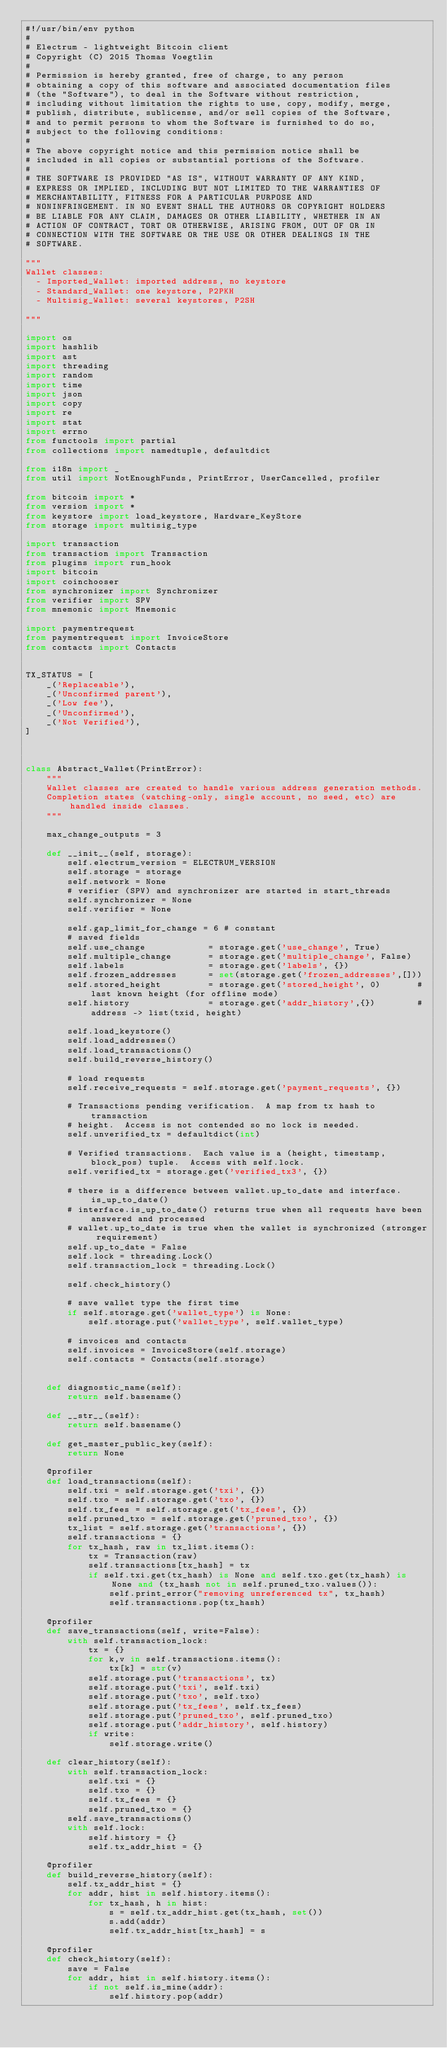Convert code to text. <code><loc_0><loc_0><loc_500><loc_500><_Python_>#!/usr/bin/env python
#
# Electrum - lightweight Bitcoin client
# Copyright (C) 2015 Thomas Voegtlin
#
# Permission is hereby granted, free of charge, to any person
# obtaining a copy of this software and associated documentation files
# (the "Software"), to deal in the Software without restriction,
# including without limitation the rights to use, copy, modify, merge,
# publish, distribute, sublicense, and/or sell copies of the Software,
# and to permit persons to whom the Software is furnished to do so,
# subject to the following conditions:
#
# The above copyright notice and this permission notice shall be
# included in all copies or substantial portions of the Software.
#
# THE SOFTWARE IS PROVIDED "AS IS", WITHOUT WARRANTY OF ANY KIND,
# EXPRESS OR IMPLIED, INCLUDING BUT NOT LIMITED TO THE WARRANTIES OF
# MERCHANTABILITY, FITNESS FOR A PARTICULAR PURPOSE AND
# NONINFRINGEMENT. IN NO EVENT SHALL THE AUTHORS OR COPYRIGHT HOLDERS
# BE LIABLE FOR ANY CLAIM, DAMAGES OR OTHER LIABILITY, WHETHER IN AN
# ACTION OF CONTRACT, TORT OR OTHERWISE, ARISING FROM, OUT OF OR IN
# CONNECTION WITH THE SOFTWARE OR THE USE OR OTHER DEALINGS IN THE
# SOFTWARE.

"""
Wallet classes:
  - Imported_Wallet: imported address, no keystore
  - Standard_Wallet: one keystore, P2PKH
  - Multisig_Wallet: several keystores, P2SH

"""

import os
import hashlib
import ast
import threading
import random
import time
import json
import copy
import re
import stat
import errno
from functools import partial
from collections import namedtuple, defaultdict

from i18n import _
from util import NotEnoughFunds, PrintError, UserCancelled, profiler

from bitcoin import *
from version import *
from keystore import load_keystore, Hardware_KeyStore
from storage import multisig_type

import transaction
from transaction import Transaction
from plugins import run_hook
import bitcoin
import coinchooser
from synchronizer import Synchronizer
from verifier import SPV
from mnemonic import Mnemonic

import paymentrequest
from paymentrequest import InvoiceStore
from contacts import Contacts


TX_STATUS = [
    _('Replaceable'),
    _('Unconfirmed parent'),
    _('Low fee'),
    _('Unconfirmed'),
    _('Not Verified'),
]



class Abstract_Wallet(PrintError):
    """
    Wallet classes are created to handle various address generation methods.
    Completion states (watching-only, single account, no seed, etc) are handled inside classes.
    """

    max_change_outputs = 3

    def __init__(self, storage):
        self.electrum_version = ELECTRUM_VERSION
        self.storage = storage
        self.network = None
        # verifier (SPV) and synchronizer are started in start_threads
        self.synchronizer = None
        self.verifier = None

        self.gap_limit_for_change = 6 # constant
        # saved fields
        self.use_change            = storage.get('use_change', True)
        self.multiple_change       = storage.get('multiple_change', False)
        self.labels                = storage.get('labels', {})
        self.frozen_addresses      = set(storage.get('frozen_addresses',[]))
        self.stored_height         = storage.get('stored_height', 0)       # last known height (for offline mode)
        self.history               = storage.get('addr_history',{})        # address -> list(txid, height)

        self.load_keystore()
        self.load_addresses()
        self.load_transactions()
        self.build_reverse_history()

        # load requests
        self.receive_requests = self.storage.get('payment_requests', {})

        # Transactions pending verification.  A map from tx hash to transaction
        # height.  Access is not contended so no lock is needed.
        self.unverified_tx = defaultdict(int)

        # Verified transactions.  Each value is a (height, timestamp, block_pos) tuple.  Access with self.lock.
        self.verified_tx = storage.get('verified_tx3', {})

        # there is a difference between wallet.up_to_date and interface.is_up_to_date()
        # interface.is_up_to_date() returns true when all requests have been answered and processed
        # wallet.up_to_date is true when the wallet is synchronized (stronger requirement)
        self.up_to_date = False
        self.lock = threading.Lock()
        self.transaction_lock = threading.Lock()

        self.check_history()

        # save wallet type the first time
        if self.storage.get('wallet_type') is None:
            self.storage.put('wallet_type', self.wallet_type)

        # invoices and contacts
        self.invoices = InvoiceStore(self.storage)
        self.contacts = Contacts(self.storage)


    def diagnostic_name(self):
        return self.basename()

    def __str__(self):
        return self.basename()

    def get_master_public_key(self):
        return None

    @profiler
    def load_transactions(self):
        self.txi = self.storage.get('txi', {})
        self.txo = self.storage.get('txo', {})
        self.tx_fees = self.storage.get('tx_fees', {})
        self.pruned_txo = self.storage.get('pruned_txo', {})
        tx_list = self.storage.get('transactions', {})
        self.transactions = {}
        for tx_hash, raw in tx_list.items():
            tx = Transaction(raw)
            self.transactions[tx_hash] = tx
            if self.txi.get(tx_hash) is None and self.txo.get(tx_hash) is None and (tx_hash not in self.pruned_txo.values()):
                self.print_error("removing unreferenced tx", tx_hash)
                self.transactions.pop(tx_hash)

    @profiler
    def save_transactions(self, write=False):
        with self.transaction_lock:
            tx = {}
            for k,v in self.transactions.items():
                tx[k] = str(v)
            self.storage.put('transactions', tx)
            self.storage.put('txi', self.txi)
            self.storage.put('txo', self.txo)
            self.storage.put('tx_fees', self.tx_fees)
            self.storage.put('pruned_txo', self.pruned_txo)
            self.storage.put('addr_history', self.history)
            if write:
                self.storage.write()

    def clear_history(self):
        with self.transaction_lock:
            self.txi = {}
            self.txo = {}
            self.tx_fees = {}
            self.pruned_txo = {}
        self.save_transactions()
        with self.lock:
            self.history = {}
            self.tx_addr_hist = {}

    @profiler
    def build_reverse_history(self):
        self.tx_addr_hist = {}
        for addr, hist in self.history.items():
            for tx_hash, h in hist:
                s = self.tx_addr_hist.get(tx_hash, set())
                s.add(addr)
                self.tx_addr_hist[tx_hash] = s

    @profiler
    def check_history(self):
        save = False
        for addr, hist in self.history.items():
            if not self.is_mine(addr):
                self.history.pop(addr)</code> 